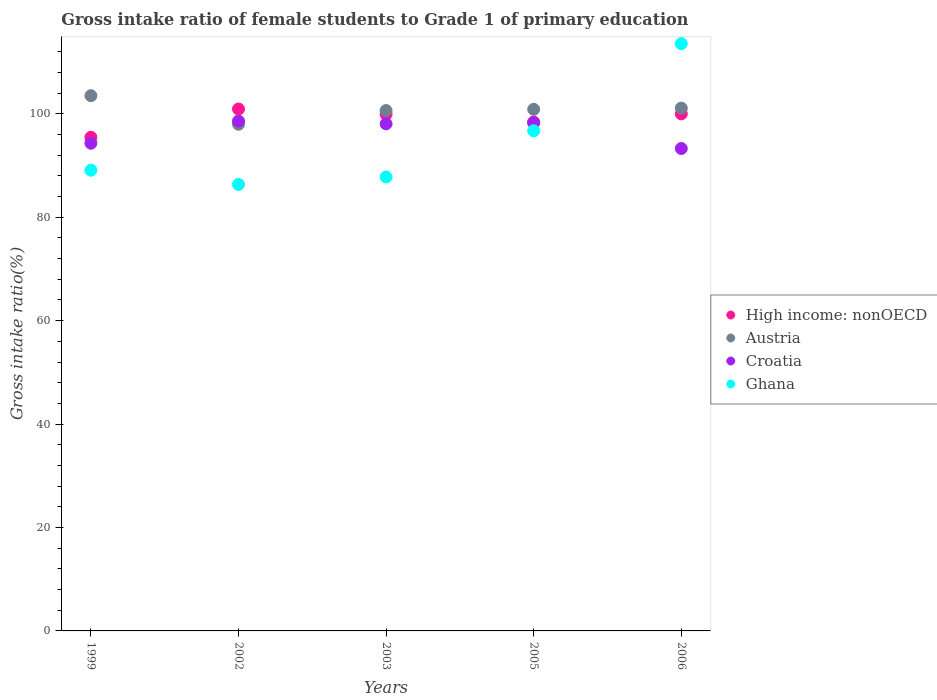Is the number of dotlines equal to the number of legend labels?
Offer a very short reply. Yes. What is the gross intake ratio in Ghana in 2002?
Your response must be concise. 86.34. Across all years, what is the maximum gross intake ratio in Austria?
Provide a succinct answer. 103.5. Across all years, what is the minimum gross intake ratio in Croatia?
Provide a short and direct response. 93.28. In which year was the gross intake ratio in Ghana maximum?
Make the answer very short. 2006. What is the total gross intake ratio in Ghana in the graph?
Your answer should be very brief. 473.5. What is the difference between the gross intake ratio in Austria in 1999 and that in 2005?
Make the answer very short. 2.64. What is the difference between the gross intake ratio in Austria in 2002 and the gross intake ratio in High income: nonOECD in 2005?
Keep it short and to the point. -0.43. What is the average gross intake ratio in High income: nonOECD per year?
Offer a terse response. 98.93. In the year 2005, what is the difference between the gross intake ratio in Croatia and gross intake ratio in Ghana?
Your response must be concise. 1.53. What is the ratio of the gross intake ratio in Ghana in 2005 to that in 2006?
Give a very brief answer. 0.85. Is the gross intake ratio in Croatia in 1999 less than that in 2005?
Provide a short and direct response. Yes. What is the difference between the highest and the second highest gross intake ratio in High income: nonOECD?
Make the answer very short. 0.93. What is the difference between the highest and the lowest gross intake ratio in High income: nonOECD?
Make the answer very short. 5.47. In how many years, is the gross intake ratio in Croatia greater than the average gross intake ratio in Croatia taken over all years?
Give a very brief answer. 3. Is the sum of the gross intake ratio in Austria in 2002 and 2006 greater than the maximum gross intake ratio in Ghana across all years?
Ensure brevity in your answer.  Yes. Is it the case that in every year, the sum of the gross intake ratio in Ghana and gross intake ratio in Croatia  is greater than the gross intake ratio in Austria?
Your response must be concise. Yes. Is the gross intake ratio in Ghana strictly greater than the gross intake ratio in Croatia over the years?
Your answer should be very brief. No. Is the gross intake ratio in High income: nonOECD strictly less than the gross intake ratio in Ghana over the years?
Keep it short and to the point. No. How many dotlines are there?
Your answer should be very brief. 4. How many years are there in the graph?
Give a very brief answer. 5. What is the difference between two consecutive major ticks on the Y-axis?
Offer a very short reply. 20. Are the values on the major ticks of Y-axis written in scientific E-notation?
Provide a short and direct response. No. Does the graph contain any zero values?
Give a very brief answer. No. Where does the legend appear in the graph?
Your response must be concise. Center right. How many legend labels are there?
Make the answer very short. 4. What is the title of the graph?
Offer a terse response. Gross intake ratio of female students to Grade 1 of primary education. Does "New Caledonia" appear as one of the legend labels in the graph?
Your answer should be very brief. No. What is the label or title of the X-axis?
Ensure brevity in your answer.  Years. What is the label or title of the Y-axis?
Your answer should be very brief. Gross intake ratio(%). What is the Gross intake ratio(%) of High income: nonOECD in 1999?
Make the answer very short. 95.45. What is the Gross intake ratio(%) of Austria in 1999?
Make the answer very short. 103.5. What is the Gross intake ratio(%) in Croatia in 1999?
Keep it short and to the point. 94.3. What is the Gross intake ratio(%) in Ghana in 1999?
Offer a terse response. 89.1. What is the Gross intake ratio(%) in High income: nonOECD in 2002?
Provide a short and direct response. 100.92. What is the Gross intake ratio(%) in Austria in 2002?
Offer a terse response. 97.98. What is the Gross intake ratio(%) in Croatia in 2002?
Provide a short and direct response. 98.59. What is the Gross intake ratio(%) in Ghana in 2002?
Your answer should be very brief. 86.34. What is the Gross intake ratio(%) in High income: nonOECD in 2003?
Ensure brevity in your answer.  99.9. What is the Gross intake ratio(%) in Austria in 2003?
Provide a succinct answer. 100.63. What is the Gross intake ratio(%) of Croatia in 2003?
Give a very brief answer. 98.06. What is the Gross intake ratio(%) of Ghana in 2003?
Offer a very short reply. 87.78. What is the Gross intake ratio(%) in High income: nonOECD in 2005?
Offer a terse response. 98.41. What is the Gross intake ratio(%) of Austria in 2005?
Give a very brief answer. 100.86. What is the Gross intake ratio(%) of Croatia in 2005?
Offer a very short reply. 98.25. What is the Gross intake ratio(%) of Ghana in 2005?
Give a very brief answer. 96.72. What is the Gross intake ratio(%) of High income: nonOECD in 2006?
Your answer should be compact. 99.99. What is the Gross intake ratio(%) in Austria in 2006?
Your answer should be compact. 101.1. What is the Gross intake ratio(%) of Croatia in 2006?
Offer a very short reply. 93.28. What is the Gross intake ratio(%) in Ghana in 2006?
Ensure brevity in your answer.  113.57. Across all years, what is the maximum Gross intake ratio(%) of High income: nonOECD?
Provide a succinct answer. 100.92. Across all years, what is the maximum Gross intake ratio(%) of Austria?
Keep it short and to the point. 103.5. Across all years, what is the maximum Gross intake ratio(%) in Croatia?
Offer a terse response. 98.59. Across all years, what is the maximum Gross intake ratio(%) in Ghana?
Provide a short and direct response. 113.57. Across all years, what is the minimum Gross intake ratio(%) of High income: nonOECD?
Offer a terse response. 95.45. Across all years, what is the minimum Gross intake ratio(%) in Austria?
Your answer should be very brief. 97.98. Across all years, what is the minimum Gross intake ratio(%) in Croatia?
Offer a terse response. 93.28. Across all years, what is the minimum Gross intake ratio(%) in Ghana?
Your answer should be compact. 86.34. What is the total Gross intake ratio(%) of High income: nonOECD in the graph?
Provide a succinct answer. 494.67. What is the total Gross intake ratio(%) in Austria in the graph?
Make the answer very short. 504.06. What is the total Gross intake ratio(%) in Croatia in the graph?
Provide a succinct answer. 482.48. What is the total Gross intake ratio(%) of Ghana in the graph?
Offer a terse response. 473.5. What is the difference between the Gross intake ratio(%) in High income: nonOECD in 1999 and that in 2002?
Provide a short and direct response. -5.47. What is the difference between the Gross intake ratio(%) in Austria in 1999 and that in 2002?
Keep it short and to the point. 5.52. What is the difference between the Gross intake ratio(%) in Croatia in 1999 and that in 2002?
Provide a short and direct response. -4.29. What is the difference between the Gross intake ratio(%) of Ghana in 1999 and that in 2002?
Your response must be concise. 2.76. What is the difference between the Gross intake ratio(%) of High income: nonOECD in 1999 and that in 2003?
Provide a succinct answer. -4.44. What is the difference between the Gross intake ratio(%) of Austria in 1999 and that in 2003?
Keep it short and to the point. 2.87. What is the difference between the Gross intake ratio(%) of Croatia in 1999 and that in 2003?
Your answer should be very brief. -3.76. What is the difference between the Gross intake ratio(%) in Ghana in 1999 and that in 2003?
Make the answer very short. 1.31. What is the difference between the Gross intake ratio(%) of High income: nonOECD in 1999 and that in 2005?
Make the answer very short. -2.95. What is the difference between the Gross intake ratio(%) in Austria in 1999 and that in 2005?
Make the answer very short. 2.64. What is the difference between the Gross intake ratio(%) in Croatia in 1999 and that in 2005?
Your response must be concise. -3.95. What is the difference between the Gross intake ratio(%) in Ghana in 1999 and that in 2005?
Make the answer very short. -7.62. What is the difference between the Gross intake ratio(%) in High income: nonOECD in 1999 and that in 2006?
Keep it short and to the point. -4.54. What is the difference between the Gross intake ratio(%) in Austria in 1999 and that in 2006?
Your response must be concise. 2.4. What is the difference between the Gross intake ratio(%) of Croatia in 1999 and that in 2006?
Give a very brief answer. 1.02. What is the difference between the Gross intake ratio(%) of Ghana in 1999 and that in 2006?
Give a very brief answer. -24.47. What is the difference between the Gross intake ratio(%) in High income: nonOECD in 2002 and that in 2003?
Offer a terse response. 1.02. What is the difference between the Gross intake ratio(%) of Austria in 2002 and that in 2003?
Offer a very short reply. -2.65. What is the difference between the Gross intake ratio(%) in Croatia in 2002 and that in 2003?
Provide a succinct answer. 0.53. What is the difference between the Gross intake ratio(%) in Ghana in 2002 and that in 2003?
Your answer should be compact. -1.44. What is the difference between the Gross intake ratio(%) of High income: nonOECD in 2002 and that in 2005?
Make the answer very short. 2.52. What is the difference between the Gross intake ratio(%) in Austria in 2002 and that in 2005?
Provide a short and direct response. -2.88. What is the difference between the Gross intake ratio(%) in Croatia in 2002 and that in 2005?
Offer a terse response. 0.33. What is the difference between the Gross intake ratio(%) in Ghana in 2002 and that in 2005?
Ensure brevity in your answer.  -10.38. What is the difference between the Gross intake ratio(%) in High income: nonOECD in 2002 and that in 2006?
Your answer should be very brief. 0.93. What is the difference between the Gross intake ratio(%) of Austria in 2002 and that in 2006?
Keep it short and to the point. -3.12. What is the difference between the Gross intake ratio(%) in Croatia in 2002 and that in 2006?
Your response must be concise. 5.3. What is the difference between the Gross intake ratio(%) in Ghana in 2002 and that in 2006?
Provide a short and direct response. -27.23. What is the difference between the Gross intake ratio(%) in High income: nonOECD in 2003 and that in 2005?
Provide a short and direct response. 1.49. What is the difference between the Gross intake ratio(%) of Austria in 2003 and that in 2005?
Give a very brief answer. -0.23. What is the difference between the Gross intake ratio(%) of Croatia in 2003 and that in 2005?
Make the answer very short. -0.19. What is the difference between the Gross intake ratio(%) of Ghana in 2003 and that in 2005?
Provide a succinct answer. -8.94. What is the difference between the Gross intake ratio(%) in High income: nonOECD in 2003 and that in 2006?
Give a very brief answer. -0.09. What is the difference between the Gross intake ratio(%) in Austria in 2003 and that in 2006?
Ensure brevity in your answer.  -0.47. What is the difference between the Gross intake ratio(%) in Croatia in 2003 and that in 2006?
Ensure brevity in your answer.  4.78. What is the difference between the Gross intake ratio(%) of Ghana in 2003 and that in 2006?
Ensure brevity in your answer.  -25.79. What is the difference between the Gross intake ratio(%) of High income: nonOECD in 2005 and that in 2006?
Keep it short and to the point. -1.58. What is the difference between the Gross intake ratio(%) in Austria in 2005 and that in 2006?
Offer a terse response. -0.24. What is the difference between the Gross intake ratio(%) in Croatia in 2005 and that in 2006?
Provide a short and direct response. 4.97. What is the difference between the Gross intake ratio(%) of Ghana in 2005 and that in 2006?
Make the answer very short. -16.85. What is the difference between the Gross intake ratio(%) of High income: nonOECD in 1999 and the Gross intake ratio(%) of Austria in 2002?
Give a very brief answer. -2.52. What is the difference between the Gross intake ratio(%) in High income: nonOECD in 1999 and the Gross intake ratio(%) in Croatia in 2002?
Give a very brief answer. -3.13. What is the difference between the Gross intake ratio(%) in High income: nonOECD in 1999 and the Gross intake ratio(%) in Ghana in 2002?
Keep it short and to the point. 9.12. What is the difference between the Gross intake ratio(%) of Austria in 1999 and the Gross intake ratio(%) of Croatia in 2002?
Keep it short and to the point. 4.91. What is the difference between the Gross intake ratio(%) of Austria in 1999 and the Gross intake ratio(%) of Ghana in 2002?
Make the answer very short. 17.16. What is the difference between the Gross intake ratio(%) in Croatia in 1999 and the Gross intake ratio(%) in Ghana in 2002?
Provide a succinct answer. 7.96. What is the difference between the Gross intake ratio(%) in High income: nonOECD in 1999 and the Gross intake ratio(%) in Austria in 2003?
Give a very brief answer. -5.17. What is the difference between the Gross intake ratio(%) in High income: nonOECD in 1999 and the Gross intake ratio(%) in Croatia in 2003?
Provide a succinct answer. -2.61. What is the difference between the Gross intake ratio(%) in High income: nonOECD in 1999 and the Gross intake ratio(%) in Ghana in 2003?
Your response must be concise. 7.67. What is the difference between the Gross intake ratio(%) of Austria in 1999 and the Gross intake ratio(%) of Croatia in 2003?
Your answer should be compact. 5.44. What is the difference between the Gross intake ratio(%) of Austria in 1999 and the Gross intake ratio(%) of Ghana in 2003?
Ensure brevity in your answer.  15.72. What is the difference between the Gross intake ratio(%) of Croatia in 1999 and the Gross intake ratio(%) of Ghana in 2003?
Offer a terse response. 6.52. What is the difference between the Gross intake ratio(%) of High income: nonOECD in 1999 and the Gross intake ratio(%) of Austria in 2005?
Provide a short and direct response. -5.41. What is the difference between the Gross intake ratio(%) in High income: nonOECD in 1999 and the Gross intake ratio(%) in Croatia in 2005?
Make the answer very short. -2.8. What is the difference between the Gross intake ratio(%) in High income: nonOECD in 1999 and the Gross intake ratio(%) in Ghana in 2005?
Give a very brief answer. -1.26. What is the difference between the Gross intake ratio(%) in Austria in 1999 and the Gross intake ratio(%) in Croatia in 2005?
Make the answer very short. 5.25. What is the difference between the Gross intake ratio(%) in Austria in 1999 and the Gross intake ratio(%) in Ghana in 2005?
Give a very brief answer. 6.78. What is the difference between the Gross intake ratio(%) in Croatia in 1999 and the Gross intake ratio(%) in Ghana in 2005?
Make the answer very short. -2.42. What is the difference between the Gross intake ratio(%) in High income: nonOECD in 1999 and the Gross intake ratio(%) in Austria in 2006?
Keep it short and to the point. -5.64. What is the difference between the Gross intake ratio(%) in High income: nonOECD in 1999 and the Gross intake ratio(%) in Croatia in 2006?
Provide a succinct answer. 2.17. What is the difference between the Gross intake ratio(%) in High income: nonOECD in 1999 and the Gross intake ratio(%) in Ghana in 2006?
Keep it short and to the point. -18.11. What is the difference between the Gross intake ratio(%) in Austria in 1999 and the Gross intake ratio(%) in Croatia in 2006?
Offer a terse response. 10.21. What is the difference between the Gross intake ratio(%) of Austria in 1999 and the Gross intake ratio(%) of Ghana in 2006?
Keep it short and to the point. -10.07. What is the difference between the Gross intake ratio(%) of Croatia in 1999 and the Gross intake ratio(%) of Ghana in 2006?
Your response must be concise. -19.27. What is the difference between the Gross intake ratio(%) in High income: nonOECD in 2002 and the Gross intake ratio(%) in Austria in 2003?
Offer a terse response. 0.29. What is the difference between the Gross intake ratio(%) of High income: nonOECD in 2002 and the Gross intake ratio(%) of Croatia in 2003?
Make the answer very short. 2.86. What is the difference between the Gross intake ratio(%) of High income: nonOECD in 2002 and the Gross intake ratio(%) of Ghana in 2003?
Offer a terse response. 13.14. What is the difference between the Gross intake ratio(%) in Austria in 2002 and the Gross intake ratio(%) in Croatia in 2003?
Offer a very short reply. -0.08. What is the difference between the Gross intake ratio(%) in Austria in 2002 and the Gross intake ratio(%) in Ghana in 2003?
Your response must be concise. 10.2. What is the difference between the Gross intake ratio(%) in Croatia in 2002 and the Gross intake ratio(%) in Ghana in 2003?
Ensure brevity in your answer.  10.81. What is the difference between the Gross intake ratio(%) of High income: nonOECD in 2002 and the Gross intake ratio(%) of Austria in 2005?
Keep it short and to the point. 0.06. What is the difference between the Gross intake ratio(%) in High income: nonOECD in 2002 and the Gross intake ratio(%) in Croatia in 2005?
Offer a terse response. 2.67. What is the difference between the Gross intake ratio(%) of High income: nonOECD in 2002 and the Gross intake ratio(%) of Ghana in 2005?
Offer a very short reply. 4.21. What is the difference between the Gross intake ratio(%) in Austria in 2002 and the Gross intake ratio(%) in Croatia in 2005?
Your response must be concise. -0.28. What is the difference between the Gross intake ratio(%) of Austria in 2002 and the Gross intake ratio(%) of Ghana in 2005?
Keep it short and to the point. 1.26. What is the difference between the Gross intake ratio(%) of Croatia in 2002 and the Gross intake ratio(%) of Ghana in 2005?
Make the answer very short. 1.87. What is the difference between the Gross intake ratio(%) of High income: nonOECD in 2002 and the Gross intake ratio(%) of Austria in 2006?
Your answer should be very brief. -0.17. What is the difference between the Gross intake ratio(%) of High income: nonOECD in 2002 and the Gross intake ratio(%) of Croatia in 2006?
Keep it short and to the point. 7.64. What is the difference between the Gross intake ratio(%) in High income: nonOECD in 2002 and the Gross intake ratio(%) in Ghana in 2006?
Keep it short and to the point. -12.65. What is the difference between the Gross intake ratio(%) of Austria in 2002 and the Gross intake ratio(%) of Croatia in 2006?
Your response must be concise. 4.69. What is the difference between the Gross intake ratio(%) in Austria in 2002 and the Gross intake ratio(%) in Ghana in 2006?
Make the answer very short. -15.59. What is the difference between the Gross intake ratio(%) in Croatia in 2002 and the Gross intake ratio(%) in Ghana in 2006?
Your answer should be very brief. -14.98. What is the difference between the Gross intake ratio(%) of High income: nonOECD in 2003 and the Gross intake ratio(%) of Austria in 2005?
Keep it short and to the point. -0.96. What is the difference between the Gross intake ratio(%) of High income: nonOECD in 2003 and the Gross intake ratio(%) of Croatia in 2005?
Provide a succinct answer. 1.65. What is the difference between the Gross intake ratio(%) in High income: nonOECD in 2003 and the Gross intake ratio(%) in Ghana in 2005?
Your answer should be compact. 3.18. What is the difference between the Gross intake ratio(%) in Austria in 2003 and the Gross intake ratio(%) in Croatia in 2005?
Give a very brief answer. 2.38. What is the difference between the Gross intake ratio(%) in Austria in 2003 and the Gross intake ratio(%) in Ghana in 2005?
Provide a succinct answer. 3.91. What is the difference between the Gross intake ratio(%) of Croatia in 2003 and the Gross intake ratio(%) of Ghana in 2005?
Give a very brief answer. 1.34. What is the difference between the Gross intake ratio(%) of High income: nonOECD in 2003 and the Gross intake ratio(%) of Austria in 2006?
Your response must be concise. -1.2. What is the difference between the Gross intake ratio(%) of High income: nonOECD in 2003 and the Gross intake ratio(%) of Croatia in 2006?
Keep it short and to the point. 6.61. What is the difference between the Gross intake ratio(%) of High income: nonOECD in 2003 and the Gross intake ratio(%) of Ghana in 2006?
Make the answer very short. -13.67. What is the difference between the Gross intake ratio(%) of Austria in 2003 and the Gross intake ratio(%) of Croatia in 2006?
Provide a succinct answer. 7.34. What is the difference between the Gross intake ratio(%) in Austria in 2003 and the Gross intake ratio(%) in Ghana in 2006?
Keep it short and to the point. -12.94. What is the difference between the Gross intake ratio(%) in Croatia in 2003 and the Gross intake ratio(%) in Ghana in 2006?
Offer a very short reply. -15.51. What is the difference between the Gross intake ratio(%) in High income: nonOECD in 2005 and the Gross intake ratio(%) in Austria in 2006?
Your answer should be compact. -2.69. What is the difference between the Gross intake ratio(%) of High income: nonOECD in 2005 and the Gross intake ratio(%) of Croatia in 2006?
Ensure brevity in your answer.  5.12. What is the difference between the Gross intake ratio(%) of High income: nonOECD in 2005 and the Gross intake ratio(%) of Ghana in 2006?
Your answer should be compact. -15.16. What is the difference between the Gross intake ratio(%) in Austria in 2005 and the Gross intake ratio(%) in Croatia in 2006?
Offer a very short reply. 7.58. What is the difference between the Gross intake ratio(%) of Austria in 2005 and the Gross intake ratio(%) of Ghana in 2006?
Ensure brevity in your answer.  -12.71. What is the difference between the Gross intake ratio(%) in Croatia in 2005 and the Gross intake ratio(%) in Ghana in 2006?
Provide a succinct answer. -15.32. What is the average Gross intake ratio(%) in High income: nonOECD per year?
Keep it short and to the point. 98.93. What is the average Gross intake ratio(%) of Austria per year?
Keep it short and to the point. 100.81. What is the average Gross intake ratio(%) of Croatia per year?
Your response must be concise. 96.5. What is the average Gross intake ratio(%) in Ghana per year?
Your answer should be compact. 94.7. In the year 1999, what is the difference between the Gross intake ratio(%) in High income: nonOECD and Gross intake ratio(%) in Austria?
Ensure brevity in your answer.  -8.04. In the year 1999, what is the difference between the Gross intake ratio(%) of High income: nonOECD and Gross intake ratio(%) of Croatia?
Make the answer very short. 1.15. In the year 1999, what is the difference between the Gross intake ratio(%) of High income: nonOECD and Gross intake ratio(%) of Ghana?
Offer a very short reply. 6.36. In the year 1999, what is the difference between the Gross intake ratio(%) of Austria and Gross intake ratio(%) of Croatia?
Make the answer very short. 9.2. In the year 1999, what is the difference between the Gross intake ratio(%) in Austria and Gross intake ratio(%) in Ghana?
Your answer should be compact. 14.4. In the year 1999, what is the difference between the Gross intake ratio(%) of Croatia and Gross intake ratio(%) of Ghana?
Provide a short and direct response. 5.21. In the year 2002, what is the difference between the Gross intake ratio(%) in High income: nonOECD and Gross intake ratio(%) in Austria?
Make the answer very short. 2.95. In the year 2002, what is the difference between the Gross intake ratio(%) in High income: nonOECD and Gross intake ratio(%) in Croatia?
Ensure brevity in your answer.  2.34. In the year 2002, what is the difference between the Gross intake ratio(%) of High income: nonOECD and Gross intake ratio(%) of Ghana?
Provide a short and direct response. 14.58. In the year 2002, what is the difference between the Gross intake ratio(%) of Austria and Gross intake ratio(%) of Croatia?
Provide a succinct answer. -0.61. In the year 2002, what is the difference between the Gross intake ratio(%) in Austria and Gross intake ratio(%) in Ghana?
Provide a short and direct response. 11.64. In the year 2002, what is the difference between the Gross intake ratio(%) of Croatia and Gross intake ratio(%) of Ghana?
Provide a short and direct response. 12.25. In the year 2003, what is the difference between the Gross intake ratio(%) in High income: nonOECD and Gross intake ratio(%) in Austria?
Your answer should be very brief. -0.73. In the year 2003, what is the difference between the Gross intake ratio(%) in High income: nonOECD and Gross intake ratio(%) in Croatia?
Offer a terse response. 1.84. In the year 2003, what is the difference between the Gross intake ratio(%) of High income: nonOECD and Gross intake ratio(%) of Ghana?
Keep it short and to the point. 12.12. In the year 2003, what is the difference between the Gross intake ratio(%) in Austria and Gross intake ratio(%) in Croatia?
Your answer should be very brief. 2.57. In the year 2003, what is the difference between the Gross intake ratio(%) of Austria and Gross intake ratio(%) of Ghana?
Offer a terse response. 12.85. In the year 2003, what is the difference between the Gross intake ratio(%) in Croatia and Gross intake ratio(%) in Ghana?
Offer a very short reply. 10.28. In the year 2005, what is the difference between the Gross intake ratio(%) in High income: nonOECD and Gross intake ratio(%) in Austria?
Ensure brevity in your answer.  -2.45. In the year 2005, what is the difference between the Gross intake ratio(%) in High income: nonOECD and Gross intake ratio(%) in Croatia?
Offer a very short reply. 0.16. In the year 2005, what is the difference between the Gross intake ratio(%) of High income: nonOECD and Gross intake ratio(%) of Ghana?
Provide a short and direct response. 1.69. In the year 2005, what is the difference between the Gross intake ratio(%) in Austria and Gross intake ratio(%) in Croatia?
Offer a terse response. 2.61. In the year 2005, what is the difference between the Gross intake ratio(%) of Austria and Gross intake ratio(%) of Ghana?
Ensure brevity in your answer.  4.14. In the year 2005, what is the difference between the Gross intake ratio(%) of Croatia and Gross intake ratio(%) of Ghana?
Your answer should be very brief. 1.53. In the year 2006, what is the difference between the Gross intake ratio(%) in High income: nonOECD and Gross intake ratio(%) in Austria?
Your response must be concise. -1.11. In the year 2006, what is the difference between the Gross intake ratio(%) of High income: nonOECD and Gross intake ratio(%) of Croatia?
Your answer should be compact. 6.71. In the year 2006, what is the difference between the Gross intake ratio(%) of High income: nonOECD and Gross intake ratio(%) of Ghana?
Offer a terse response. -13.58. In the year 2006, what is the difference between the Gross intake ratio(%) in Austria and Gross intake ratio(%) in Croatia?
Provide a succinct answer. 7.81. In the year 2006, what is the difference between the Gross intake ratio(%) of Austria and Gross intake ratio(%) of Ghana?
Provide a short and direct response. -12.47. In the year 2006, what is the difference between the Gross intake ratio(%) in Croatia and Gross intake ratio(%) in Ghana?
Offer a terse response. -20.28. What is the ratio of the Gross intake ratio(%) of High income: nonOECD in 1999 to that in 2002?
Keep it short and to the point. 0.95. What is the ratio of the Gross intake ratio(%) of Austria in 1999 to that in 2002?
Your response must be concise. 1.06. What is the ratio of the Gross intake ratio(%) in Croatia in 1999 to that in 2002?
Offer a very short reply. 0.96. What is the ratio of the Gross intake ratio(%) in Ghana in 1999 to that in 2002?
Your answer should be compact. 1.03. What is the ratio of the Gross intake ratio(%) in High income: nonOECD in 1999 to that in 2003?
Offer a terse response. 0.96. What is the ratio of the Gross intake ratio(%) of Austria in 1999 to that in 2003?
Your answer should be compact. 1.03. What is the ratio of the Gross intake ratio(%) of Croatia in 1999 to that in 2003?
Offer a very short reply. 0.96. What is the ratio of the Gross intake ratio(%) in Ghana in 1999 to that in 2003?
Offer a terse response. 1.01. What is the ratio of the Gross intake ratio(%) of Austria in 1999 to that in 2005?
Make the answer very short. 1.03. What is the ratio of the Gross intake ratio(%) in Croatia in 1999 to that in 2005?
Make the answer very short. 0.96. What is the ratio of the Gross intake ratio(%) in Ghana in 1999 to that in 2005?
Your answer should be very brief. 0.92. What is the ratio of the Gross intake ratio(%) in High income: nonOECD in 1999 to that in 2006?
Your answer should be compact. 0.95. What is the ratio of the Gross intake ratio(%) of Austria in 1999 to that in 2006?
Give a very brief answer. 1.02. What is the ratio of the Gross intake ratio(%) in Croatia in 1999 to that in 2006?
Offer a terse response. 1.01. What is the ratio of the Gross intake ratio(%) in Ghana in 1999 to that in 2006?
Your answer should be very brief. 0.78. What is the ratio of the Gross intake ratio(%) in High income: nonOECD in 2002 to that in 2003?
Give a very brief answer. 1.01. What is the ratio of the Gross intake ratio(%) of Austria in 2002 to that in 2003?
Make the answer very short. 0.97. What is the ratio of the Gross intake ratio(%) of Croatia in 2002 to that in 2003?
Ensure brevity in your answer.  1.01. What is the ratio of the Gross intake ratio(%) in Ghana in 2002 to that in 2003?
Provide a short and direct response. 0.98. What is the ratio of the Gross intake ratio(%) of High income: nonOECD in 2002 to that in 2005?
Offer a terse response. 1.03. What is the ratio of the Gross intake ratio(%) of Austria in 2002 to that in 2005?
Your answer should be very brief. 0.97. What is the ratio of the Gross intake ratio(%) of Croatia in 2002 to that in 2005?
Give a very brief answer. 1. What is the ratio of the Gross intake ratio(%) of Ghana in 2002 to that in 2005?
Offer a terse response. 0.89. What is the ratio of the Gross intake ratio(%) in High income: nonOECD in 2002 to that in 2006?
Make the answer very short. 1.01. What is the ratio of the Gross intake ratio(%) of Austria in 2002 to that in 2006?
Your answer should be compact. 0.97. What is the ratio of the Gross intake ratio(%) of Croatia in 2002 to that in 2006?
Your response must be concise. 1.06. What is the ratio of the Gross intake ratio(%) in Ghana in 2002 to that in 2006?
Keep it short and to the point. 0.76. What is the ratio of the Gross intake ratio(%) of High income: nonOECD in 2003 to that in 2005?
Provide a short and direct response. 1.02. What is the ratio of the Gross intake ratio(%) of Ghana in 2003 to that in 2005?
Provide a short and direct response. 0.91. What is the ratio of the Gross intake ratio(%) of High income: nonOECD in 2003 to that in 2006?
Ensure brevity in your answer.  1. What is the ratio of the Gross intake ratio(%) in Austria in 2003 to that in 2006?
Ensure brevity in your answer.  1. What is the ratio of the Gross intake ratio(%) of Croatia in 2003 to that in 2006?
Offer a very short reply. 1.05. What is the ratio of the Gross intake ratio(%) in Ghana in 2003 to that in 2006?
Your answer should be very brief. 0.77. What is the ratio of the Gross intake ratio(%) of High income: nonOECD in 2005 to that in 2006?
Provide a succinct answer. 0.98. What is the ratio of the Gross intake ratio(%) of Croatia in 2005 to that in 2006?
Provide a short and direct response. 1.05. What is the ratio of the Gross intake ratio(%) of Ghana in 2005 to that in 2006?
Your answer should be compact. 0.85. What is the difference between the highest and the second highest Gross intake ratio(%) in High income: nonOECD?
Make the answer very short. 0.93. What is the difference between the highest and the second highest Gross intake ratio(%) of Austria?
Provide a short and direct response. 2.4. What is the difference between the highest and the second highest Gross intake ratio(%) in Croatia?
Keep it short and to the point. 0.33. What is the difference between the highest and the second highest Gross intake ratio(%) of Ghana?
Offer a very short reply. 16.85. What is the difference between the highest and the lowest Gross intake ratio(%) of High income: nonOECD?
Make the answer very short. 5.47. What is the difference between the highest and the lowest Gross intake ratio(%) in Austria?
Give a very brief answer. 5.52. What is the difference between the highest and the lowest Gross intake ratio(%) of Croatia?
Your response must be concise. 5.3. What is the difference between the highest and the lowest Gross intake ratio(%) of Ghana?
Provide a succinct answer. 27.23. 